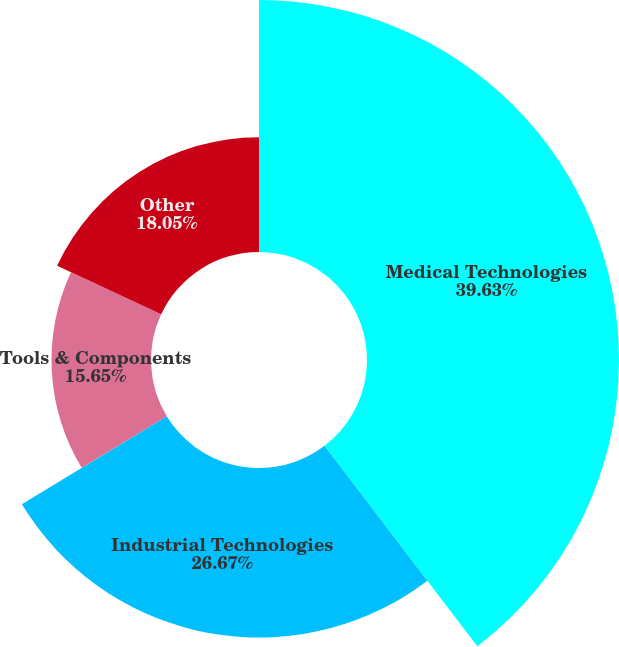<chart> <loc_0><loc_0><loc_500><loc_500><pie_chart><fcel>Medical Technologies<fcel>Industrial Technologies<fcel>Tools & Components<fcel>Other<nl><fcel>39.63%<fcel>26.67%<fcel>15.65%<fcel>18.05%<nl></chart> 